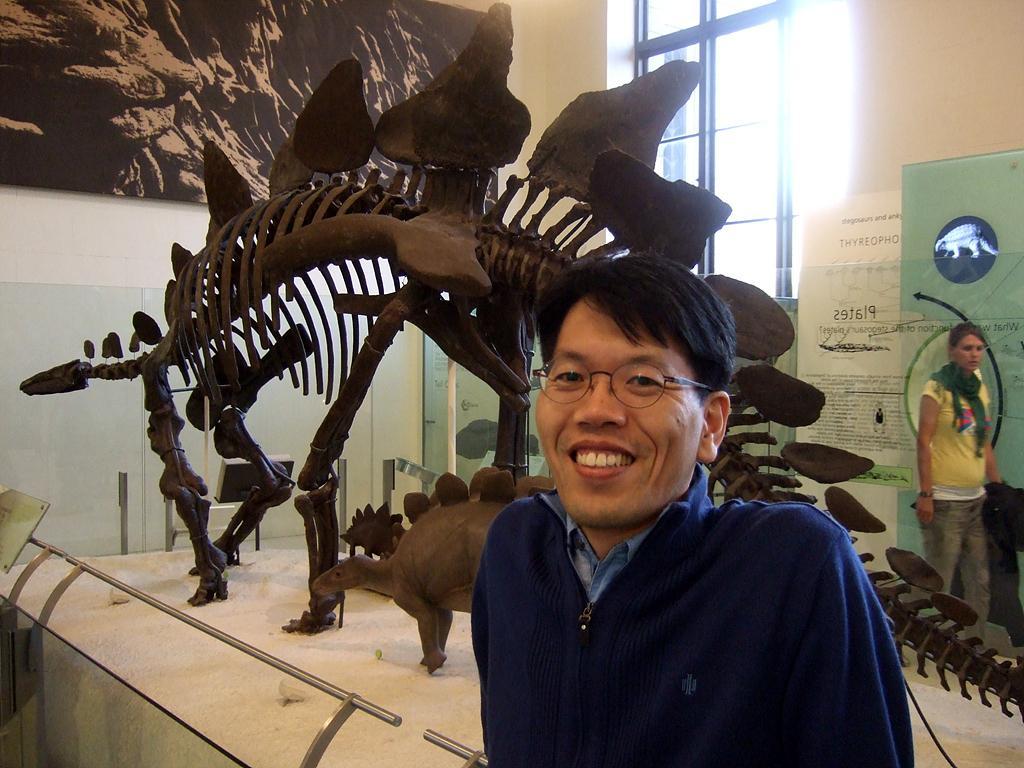Please provide a concise description of this image. In this image there is a table, on that table there are dinosaur sculptures and a person standing near the table, in the background there is a wall for that wall there is a window and a photo frame and there is a banner, on that banner there is some text and there is a picture. 